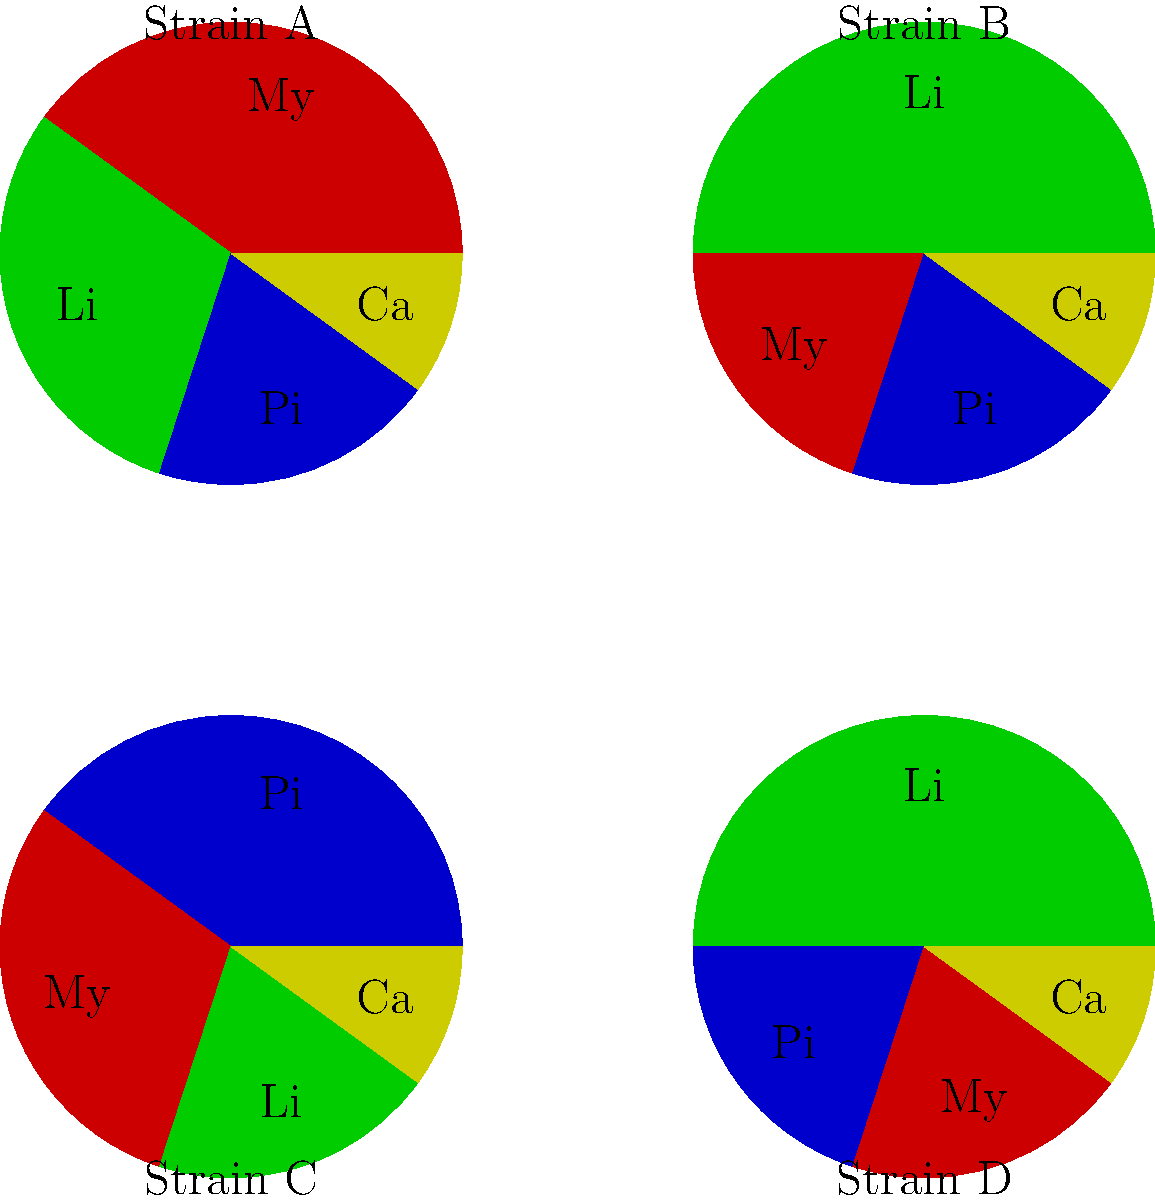Match the following cannabis strain descriptions to their corresponding terpene wheel representations shown above:

1. A strain with a dominant limonene profile, followed by myrcene, pinene, and caryophyllene.
2. A strain with a balanced profile of myrcene and limonene, with pinene and caryophyllene in smaller amounts.
3. A strain characterized by high myrcene content, with limonene, pinene, and caryophyllene in decreasing order.
4. A strain with pinene as the primary terpene, followed by myrcene, limonene, and caryophyllene. To match the strain descriptions to their terpene wheel representations, we need to analyze each wheel and compare it to the given descriptions:

1. Strain with dominant limonene, followed by myrcene, pinene, and caryophyllene:
   - This matches Strain B, where the green section (Li for limonene) is largest, followed by red (My for myrcene), blue (Pi for pinene), and yellow (Ca for caryophyllene).

2. Balanced profile of myrcene and limonene, with pinene and caryophyllene in smaller amounts:
   - This corresponds to Strain A, where red (My for myrcene) and green (Li for limonene) sections are similar in size and larger than blue (Pi for pinene) and yellow (Ca for caryophyllene).

3. High myrcene content, with limonene, pinene, and caryophyllene in decreasing order:
   - This matches Strain D, where the red section (My for myrcene) is largest, followed by green (Li for limonene), blue (Pi for pinene), and yellow (Ca for caryophyllene).

4. Pinene as primary terpene, followed by myrcene, limonene, and caryophyllene:
   - This corresponds to Strain C, where the blue section (Pi for pinene) is largest, followed by red (My for myrcene), green (Li for limonene), and yellow (Ca for caryophyllene).
Answer: 1-B, 2-A, 3-D, 4-C 